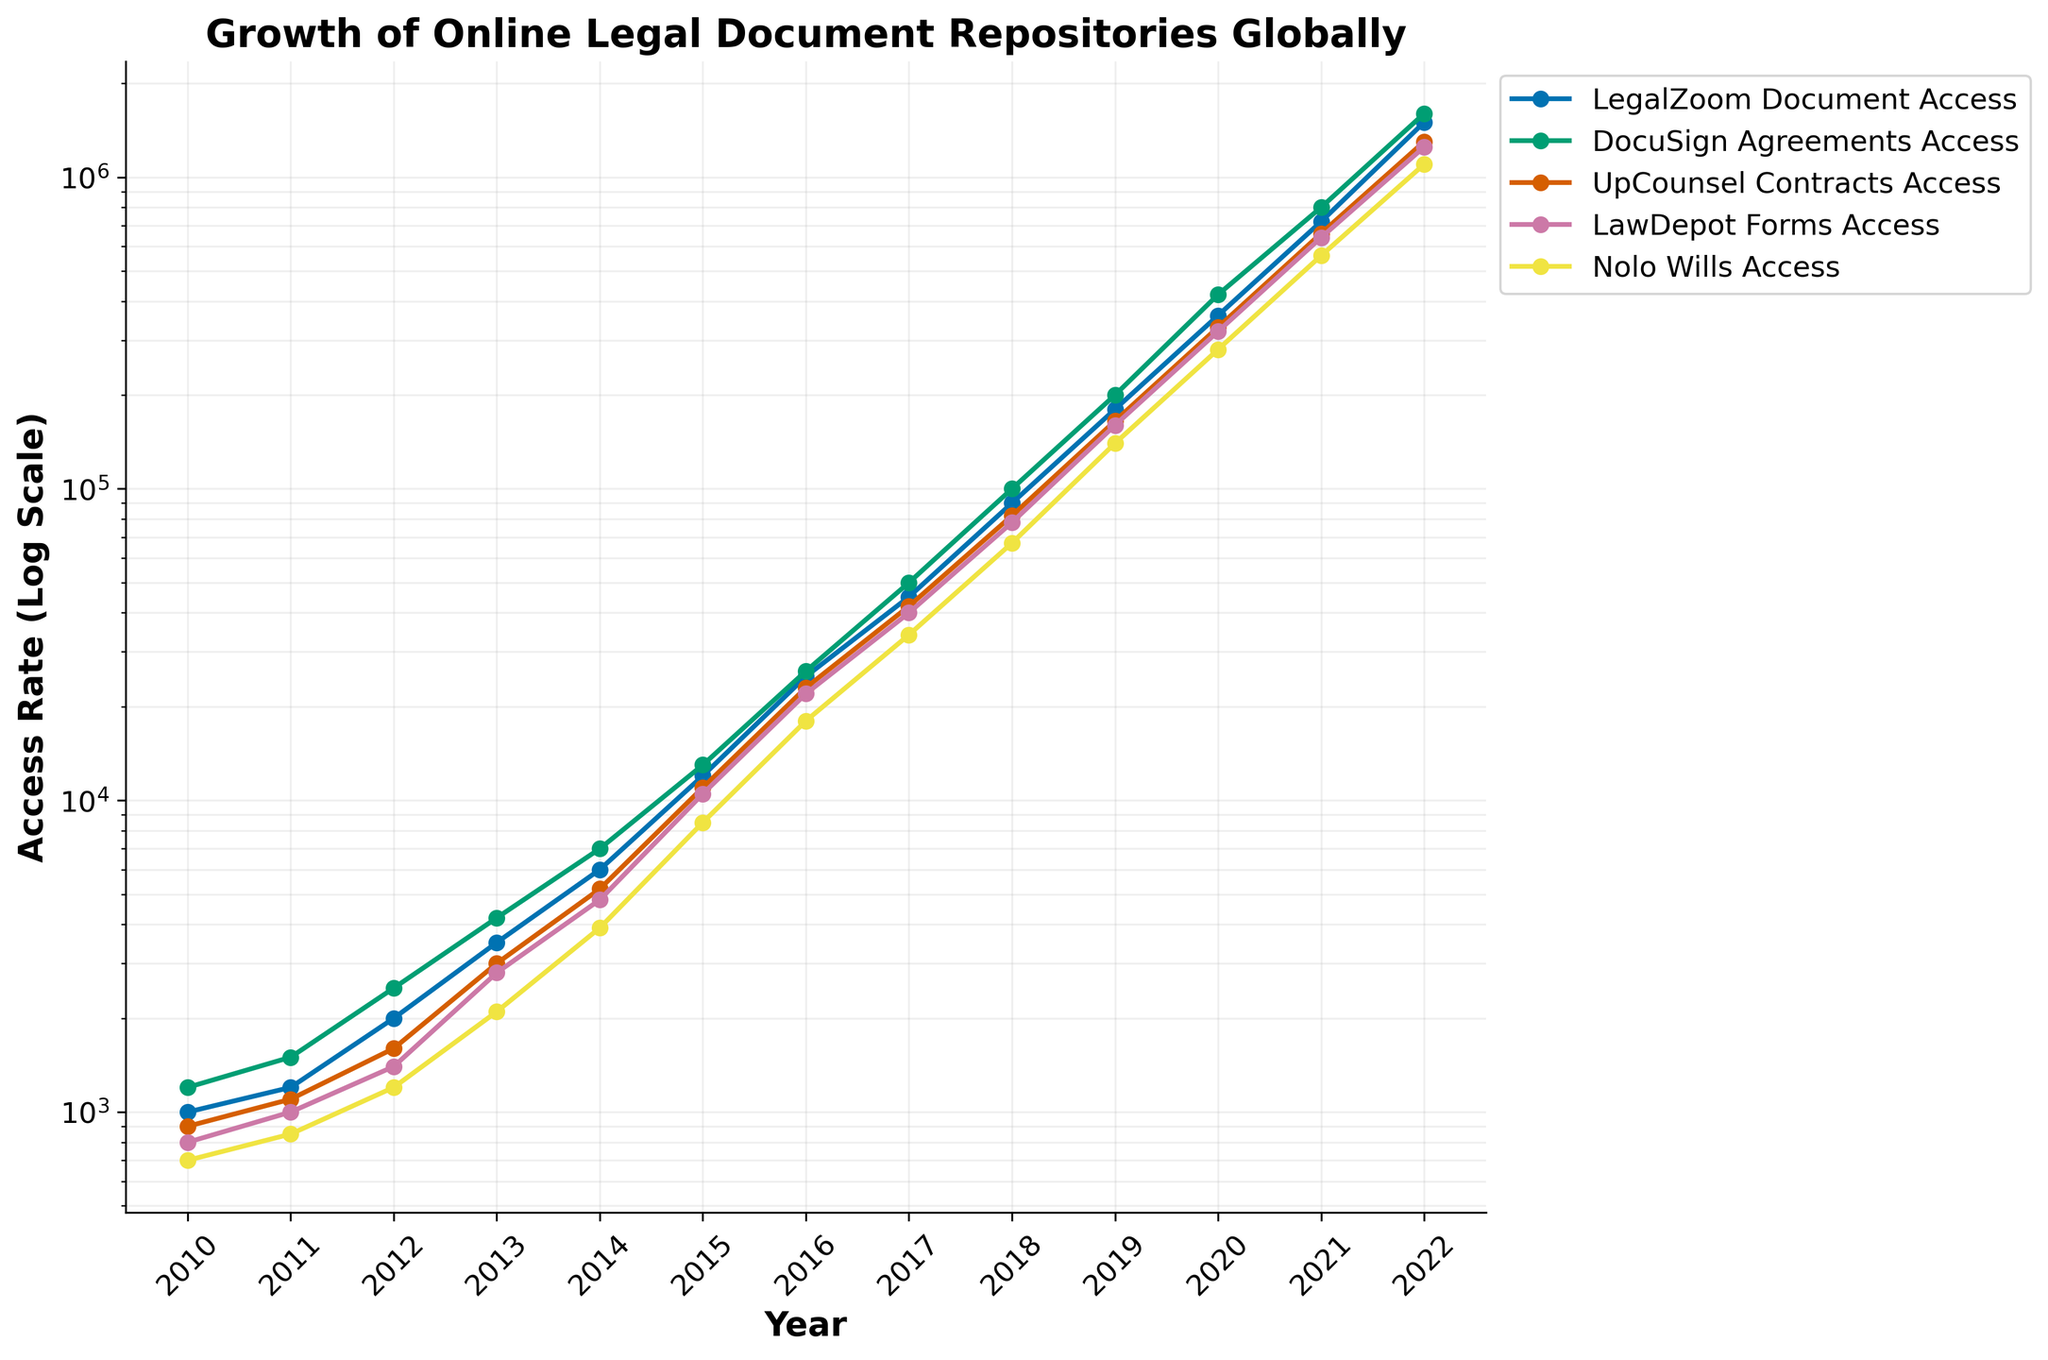Which legal document repository showed the highest access rate in 2022? By looking at the graph and focusing on the endpoint for the year 2022, we see that 'DocuSign Agreements Access' has the highest line position compared to other repositories.
Answer: DocuSign Agreements Access How did the access rate for Nolo Wills change from 2010 to 2022? By examining the year 2010 and 2022 data points for 'Nolo Wills Access', we observe that it started around 700 in 2010 and increased to 1,100,000 by 2022. Subtracting the initial value from the final value shows the change: 1,100,000 - 700 = 1,099,300.
Answer: Increased by 1,099,300 Compare the access rates of LegalZoom Documents and LawDepot Forms in 2015. Which had more access? For the year 2015, 'LegalZoom Documents Access' is roughly at 12,000, while 'LawDepot Forms Access' is around 10,500. Therefore, LegalZoom Documents had a higher access rate.
Answer: LegalZoom Documents What is the general trend observed in the plot for all the legal document repositories from 2010 to 2022? Observing the entire timeline, all document repositories show an upward trajectory starting from relatively lower values in 2010 to significantly higher values in 2022, indicating exponential growth.
Answer: Exponential growth In which year did DocuSign Agreements Access surpass 100,000? Looking at the data points for 'DocuSign Agreements Access', it is clear that it surpasses 100,000 between 2017 (50,000) and 2018 (100,000). Thus, it surpassed 100,000 in 2018.
Answer: 2018 What is the difference in access rates between UpCounsel Contracts and Nolo Wills in 2019? For the year 2019, 'UpCounsel Contracts Access' is at 165,000 and 'Nolo Wills Access' is at 140,000. Subtracting these values gives the difference: 165,000 - 140,000 = 25,000.
Answer: 25,000 Which legal document repository had approximately a tenfold increase in access rate from 2010 to 2013? Comparing 2010 and 2013 data points, 'UpCounsel Contracts Access' increased from 900 to 3,000, which is not tenfold. 'Nolo Wills Access' increased from 700 to 2,100, which is also not tenfold. 'LegalZoom Documents Access' went from 1,000 to 3,500, 'DocuSign Agreements Access' from 1,200 to 4,200, and 'LawDepot Forms Access' from 800 to 2,800, none of which are tenfold. Thus, no repository had approximately a tenfold increase.
Answer: None Which year showed the most significant jump in access rate for LawDepot Forms? Observing 'LawDepot Forms Access', 2019 (160,000) to 2020 (320,000) was the biggest jump, doubling (increase of 160,000) compared to other year-to-year increments.
Answer: 2020 Calculate the average access rate for Nolo Wills over the span of 2010 to 2022. Summing up the access rates for all years and dividing by the number of years, (700 + 850 + 1,200 + 2,100 + 3,900 + 8,500 + 18,000 + 34,000 + 67,000 + 140,000 + 280,000 + 560,000 + 1,100,000) / 13 = 178,129.
Answer: 178,129 